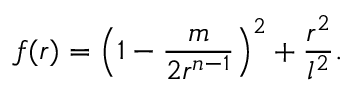<formula> <loc_0><loc_0><loc_500><loc_500>f ( r ) = \left ( 1 - \frac { m } { 2 r ^ { n - 1 } } \right ) ^ { 2 } + \frac { r ^ { 2 } } { l ^ { 2 } } .</formula> 